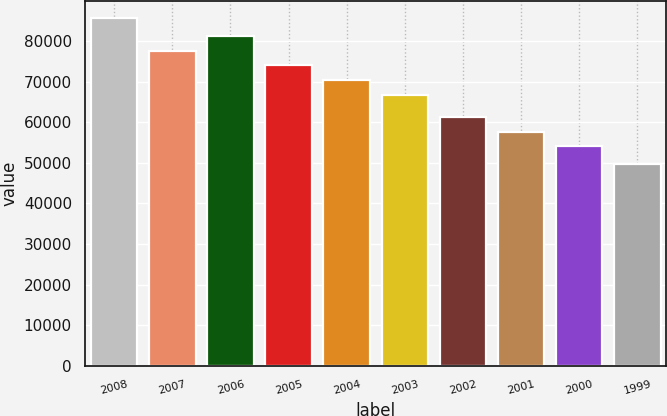Convert chart. <chart><loc_0><loc_0><loc_500><loc_500><bar_chart><fcel>2008<fcel>2007<fcel>2006<fcel>2005<fcel>2004<fcel>2003<fcel>2002<fcel>2001<fcel>2000<fcel>1999<nl><fcel>85659<fcel>77636.9<fcel>81228.2<fcel>74045.6<fcel>70454.3<fcel>66863<fcel>61328.6<fcel>57737.3<fcel>54146<fcel>49746<nl></chart> 